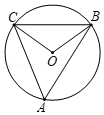Assuming angle A was not given, how could we determine its measure based on other provided information? Without a direct measure of angle A, one would typically need additional information to determine its measure. For instance, if we knew the length of any sides of triangles OAB or OAC or the length of arc BC, we could use various geometric rules and theorems to solve for angle A. In the case where another inscribed angle that subtends the same arc as angle A is known, angle A could be directly calculated using its measure due to the property that inscribed angles subtending the same arc are equal. 